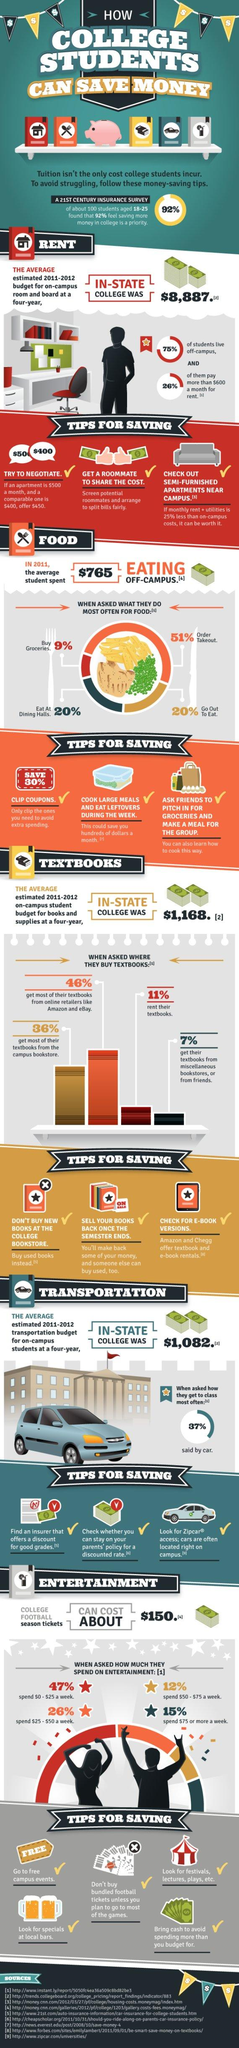List a handful of essential elements in this visual. According to a recent survey, a staggering 71% of college students order takeout or go out to eat. According to the data, 82% of students do not purchase their books from the campus bookstore or online. 